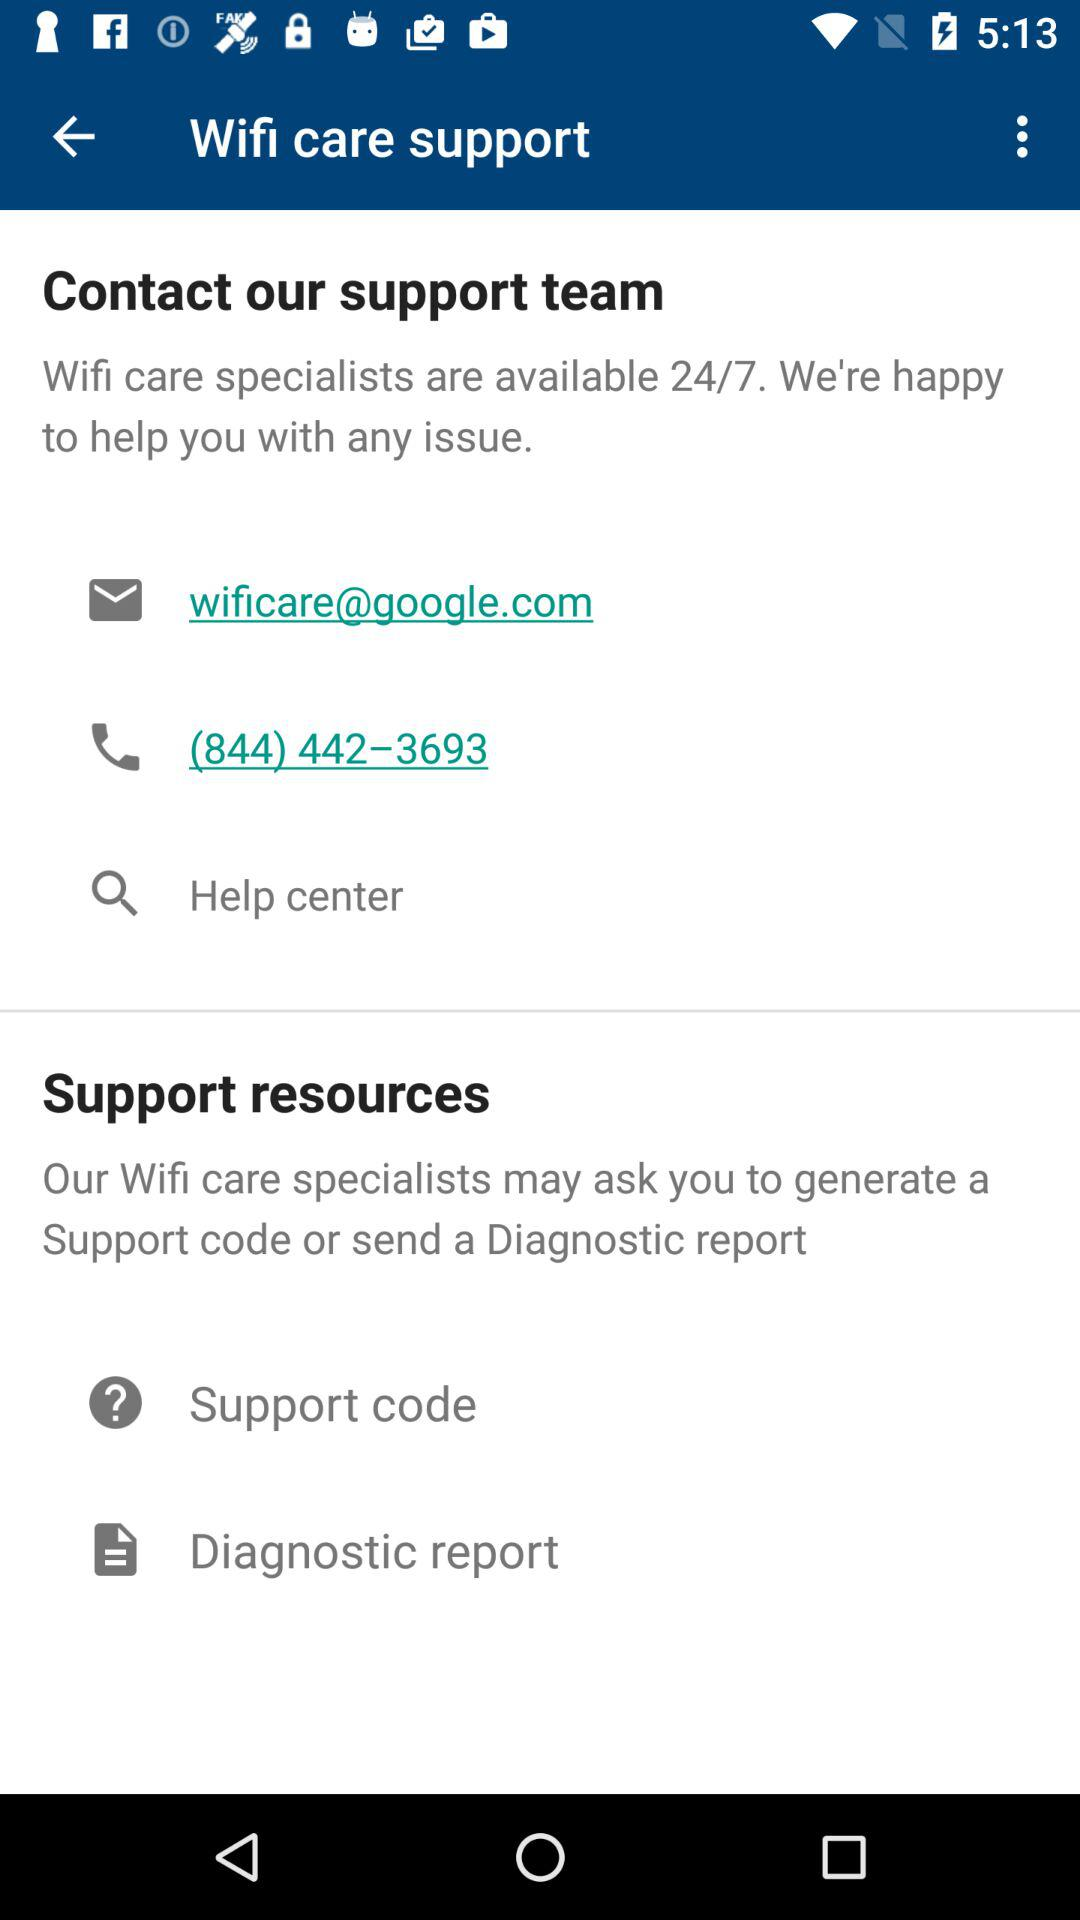How many contact options are available?
Answer the question using a single word or phrase. 3 